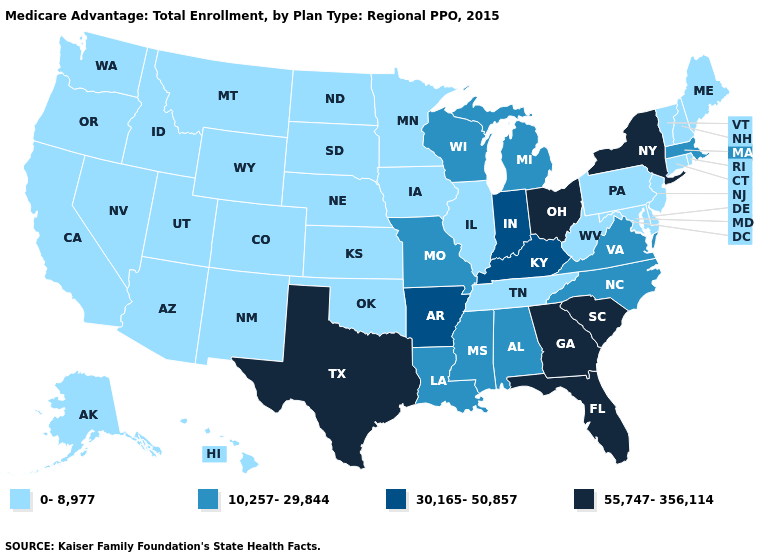Name the states that have a value in the range 30,165-50,857?
Answer briefly. Arkansas, Indiana, Kentucky. Among the states that border Tennessee , does Virginia have the lowest value?
Quick response, please. Yes. What is the highest value in the West ?
Concise answer only. 0-8,977. What is the lowest value in the MidWest?
Answer briefly. 0-8,977. Which states have the highest value in the USA?
Be succinct. Florida, Georgia, New York, Ohio, South Carolina, Texas. What is the highest value in states that border Virginia?
Concise answer only. 30,165-50,857. What is the highest value in the MidWest ?
Be succinct. 55,747-356,114. Does North Carolina have the lowest value in the USA?
Keep it brief. No. Which states hav the highest value in the West?
Write a very short answer. Alaska, Arizona, California, Colorado, Hawaii, Idaho, Montana, New Mexico, Nevada, Oregon, Utah, Washington, Wyoming. Does Ohio have the lowest value in the MidWest?
Be succinct. No. Does New York have the same value as Utah?
Answer briefly. No. What is the lowest value in the USA?
Concise answer only. 0-8,977. Does Illinois have the lowest value in the MidWest?
Short answer required. Yes. What is the lowest value in the MidWest?
Write a very short answer. 0-8,977. What is the value of Maryland?
Be succinct. 0-8,977. 